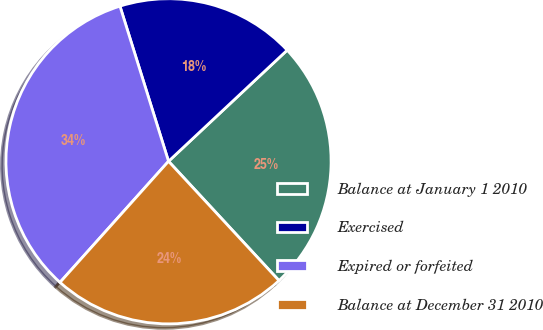Convert chart to OTSL. <chart><loc_0><loc_0><loc_500><loc_500><pie_chart><fcel>Balance at January 1 2010<fcel>Exercised<fcel>Expired or forfeited<fcel>Balance at December 31 2010<nl><fcel>25.09%<fcel>17.85%<fcel>33.54%<fcel>23.52%<nl></chart> 